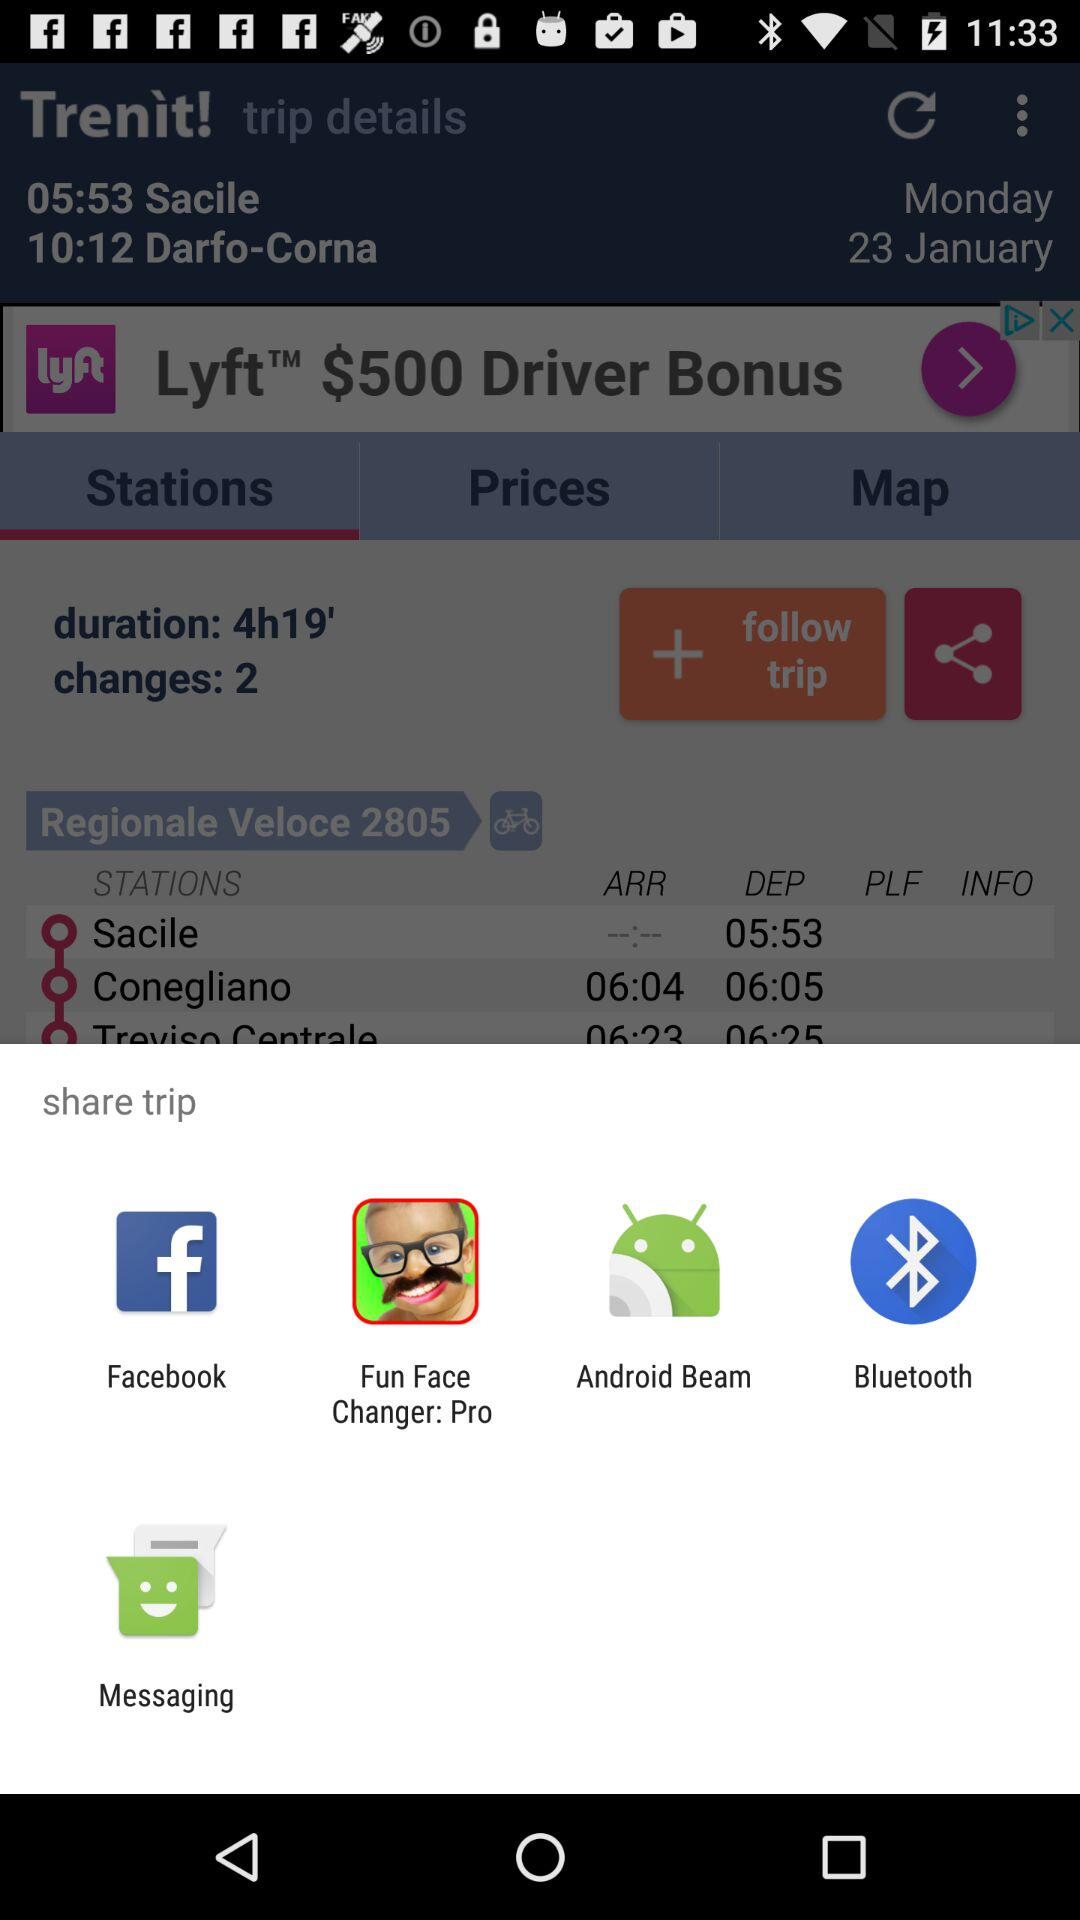Through which application can I share? You can share through "Facebook", "Fun Face Changer: Pro", "Android Beam", "Bluetooth" and "Messaging". 